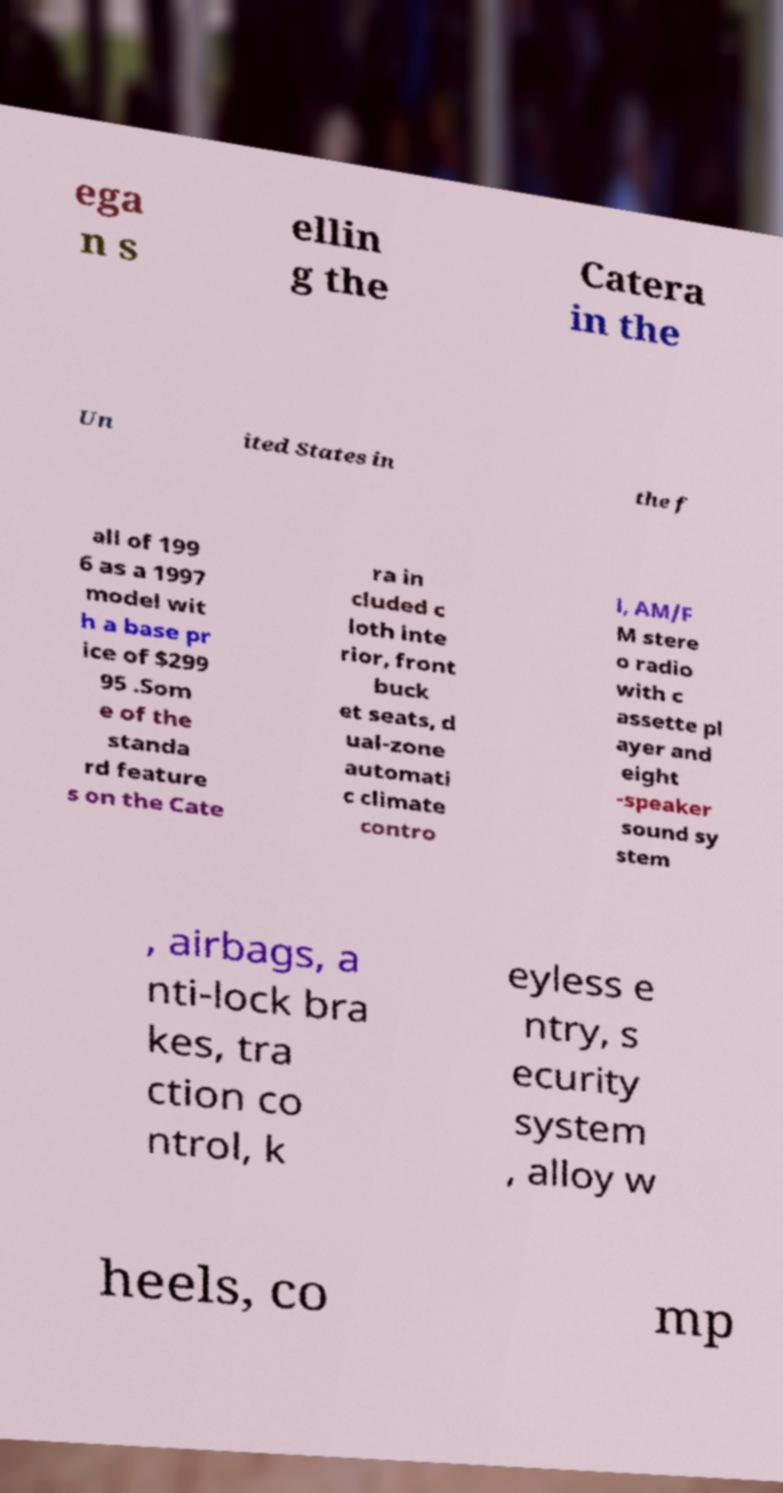Could you extract and type out the text from this image? ega n s ellin g the Catera in the Un ited States in the f all of 199 6 as a 1997 model wit h a base pr ice of $299 95 .Som e of the standa rd feature s on the Cate ra in cluded c loth inte rior, front buck et seats, d ual-zone automati c climate contro l, AM/F M stere o radio with c assette pl ayer and eight -speaker sound sy stem , airbags, a nti-lock bra kes, tra ction co ntrol, k eyless e ntry, s ecurity system , alloy w heels, co mp 